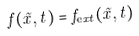<formula> <loc_0><loc_0><loc_500><loc_500>f ( \tilde { x } , t ) = f _ { \mathrm e x t } ( \tilde { x } , t )</formula> 